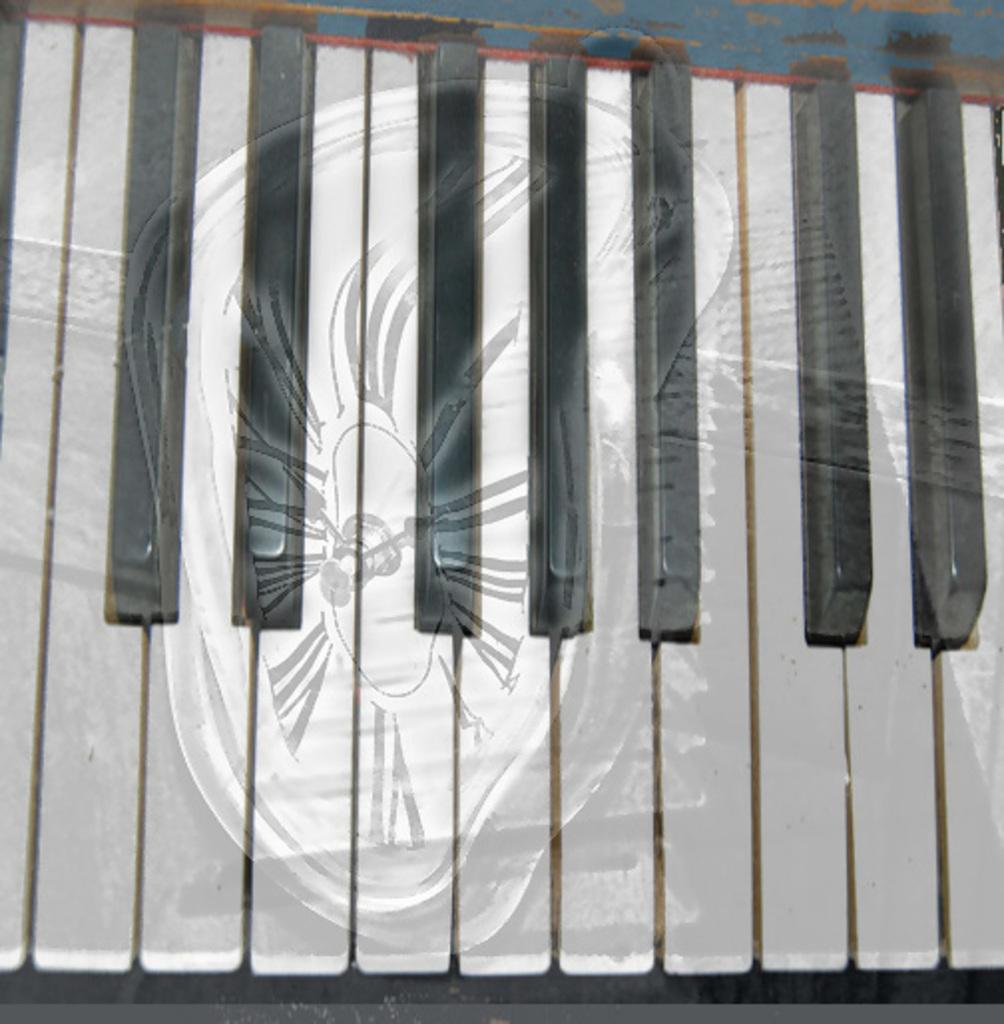In one or two sentences, can you explain what this image depicts? In the image we can see there is a keypad of piano or casio. 